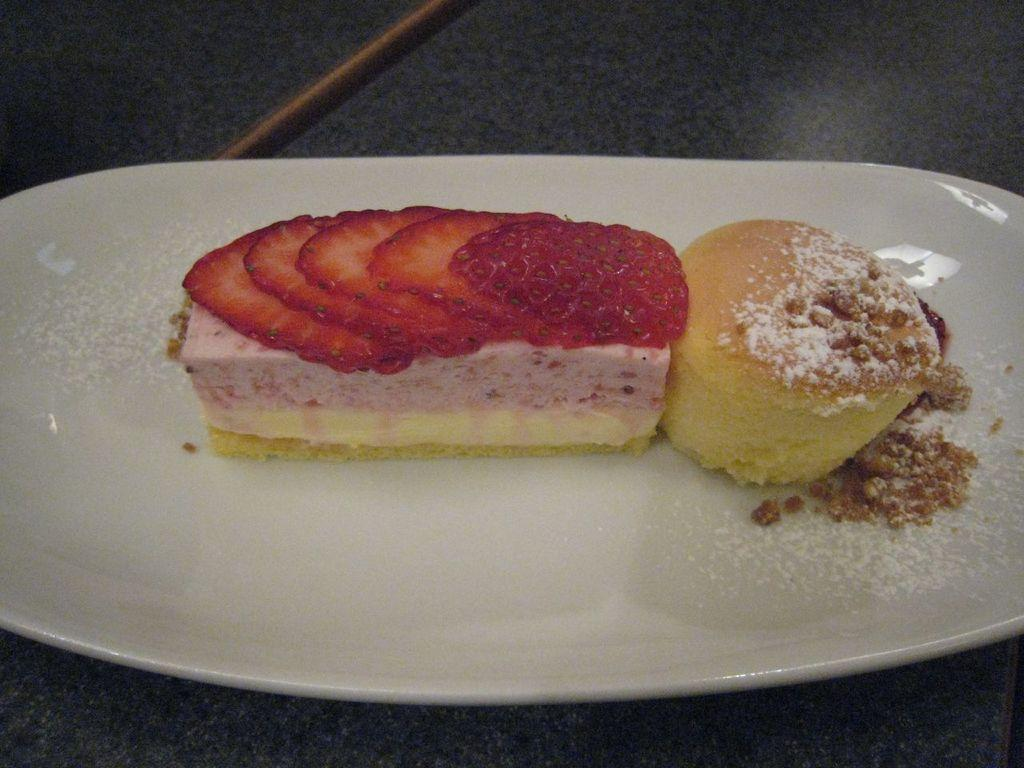What is the main object in the center of the image? There is a plate in the center of the image. What is on the plate? The plate contains pastries. Is there any furniture or surface visible in the image? There might be a table at the bottom of the image. What type of noise can be heard coming from the tiger in the image? There is no tiger present in the image, so no noise can be heard from a tiger. 